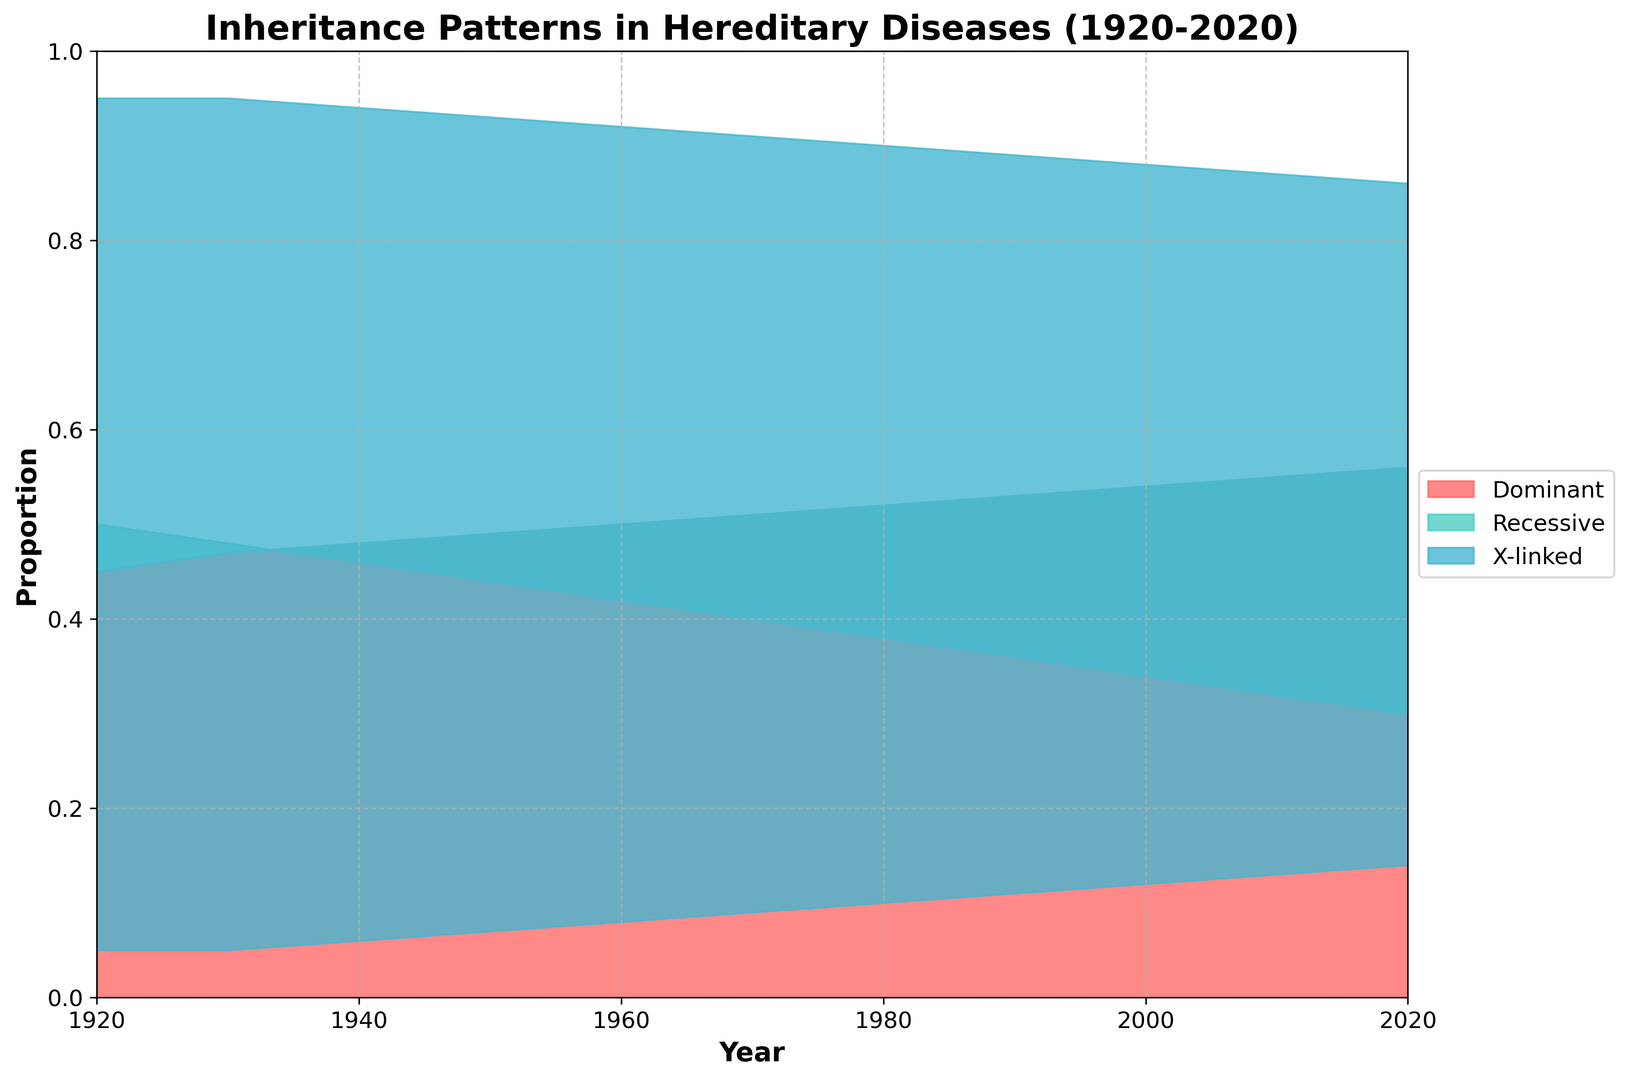Which inheritance pattern had the highest proportion in 1920? By examining the leftmost part of the area chart for the year 1920 and looking at the different colored sections, the highest proportion is indicated by the section with the deepest height, which is the red section for the dominant pattern.
Answer: Dominant How did the proportion of recessive inheritance patterns change from 1920 to 2020? To find the change, look at the heights of the turquoise section in 1920 and 2020. In 1920, recessive patterns had a proportion of 0.50, and by 2020, this proportion dropped to 0.30. Subtract 0.30 from 0.50 to determine the change.
Answer: Decreased by 0.20 Compare the proportions of X-linked inheritance patterns in 1950 and 1980. Which was higher? Locate the blue section of the area chart for the years 1950 and 1980. In 1950, the proportion is 0.07, and in 1980, it is 0.10. Comparing these values, 0.10 is greater than 0.07.
Answer: 1980 What is the general trend of the dominant inheritance pattern over the century? Observe the red section from 1920 to 2020; the height steadily increases, indicating a rise in the proportion of dominant inheritance patterns.
Answer: Increasing What was the combined proportion of dominant and recessive inheritance patterns in 2010? For the year 2010, add the dominant proportion (0.55) and the recessive proportion (0.32) together. The sum is 0.55 + 0.32 = 0.87.
Answer: 0.87 Which inheritance pattern showed the least variation in proportion over the past century? Compare the variations for dominant, recessive, and X-linked patterns. Dominant and recessive show notable changes, while X-linked moves from 0.05 to 0.14, a smaller range of variation.
Answer: X-linked In which decade did the proportion of recessive inheritance patterns drop below 0.40 for the first time? Follow the turquoise section and observe the height for each decade. The value falls below 0.40 in the decade between 1970 and 1980.
Answer: 1980s What was the proportion of dominant inheritance patterns in the mid-20th century (1950)? Locate the red section's height in 1950, which is clearly marked at the midpoint of the century. The given value is 0.49.
Answer: 0.49 